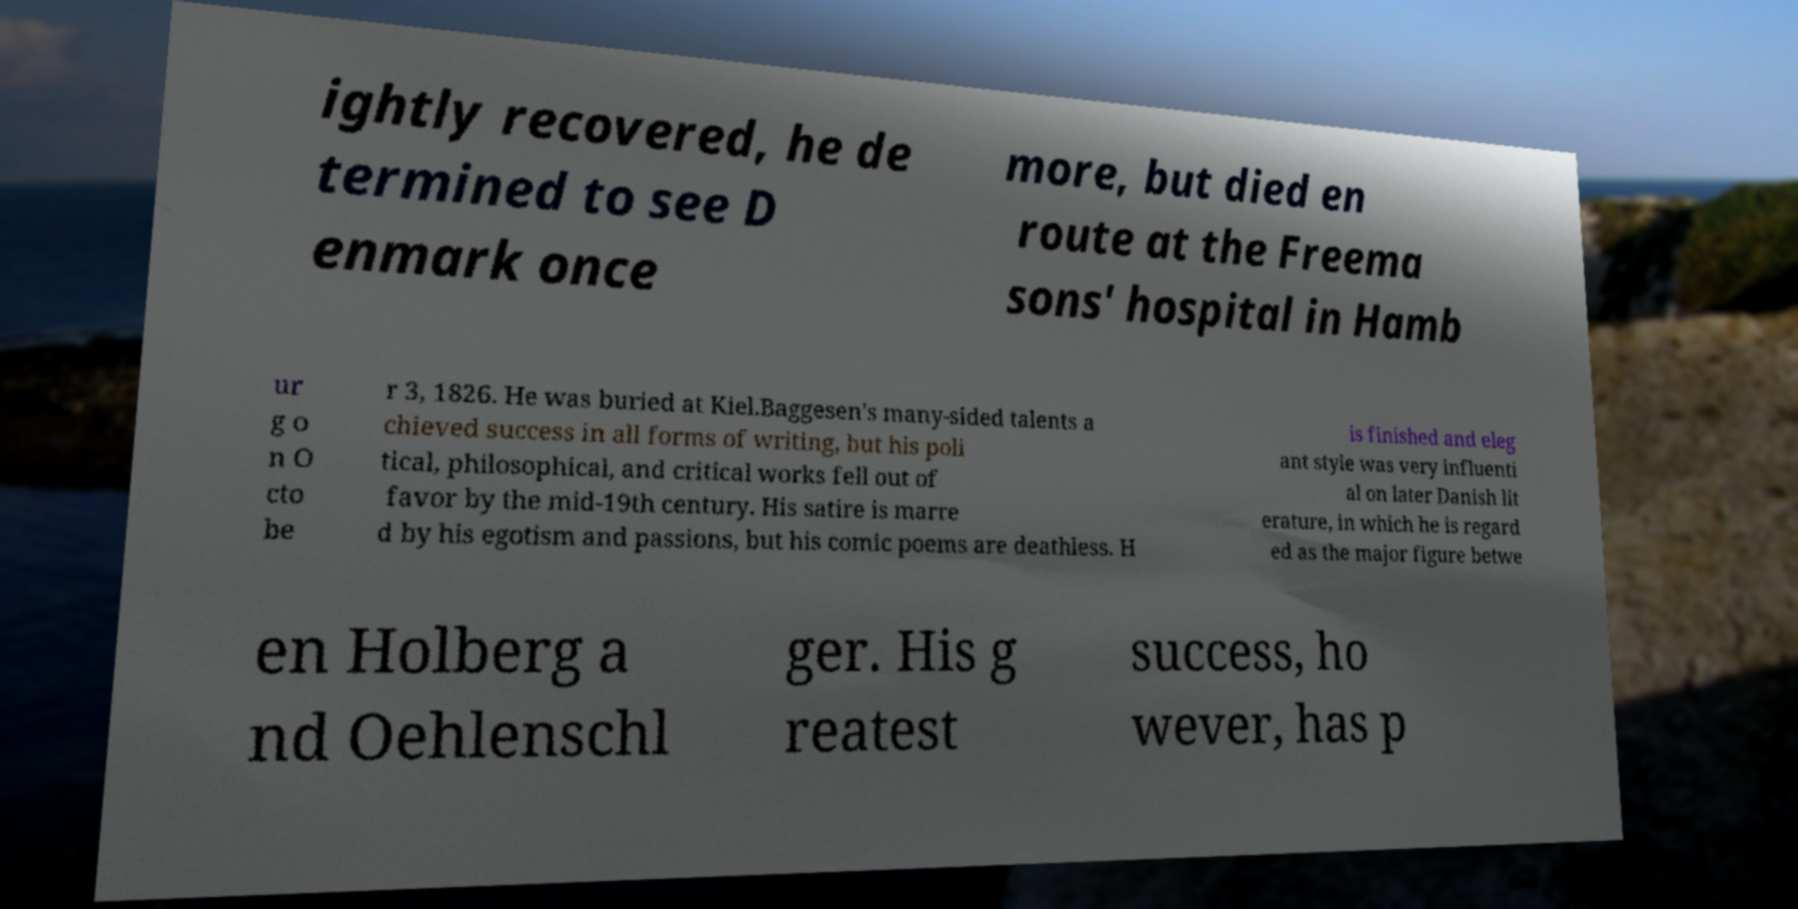Please identify and transcribe the text found in this image. ightly recovered, he de termined to see D enmark once more, but died en route at the Freema sons' hospital in Hamb ur g o n O cto be r 3, 1826. He was buried at Kiel.Baggesen's many-sided talents a chieved success in all forms of writing, but his poli tical, philosophical, and critical works fell out of favor by the mid-19th century. His satire is marre d by his egotism and passions, but his comic poems are deathless. H is finished and eleg ant style was very influenti al on later Danish lit erature, in which he is regard ed as the major figure betwe en Holberg a nd Oehlenschl ger. His g reatest success, ho wever, has p 